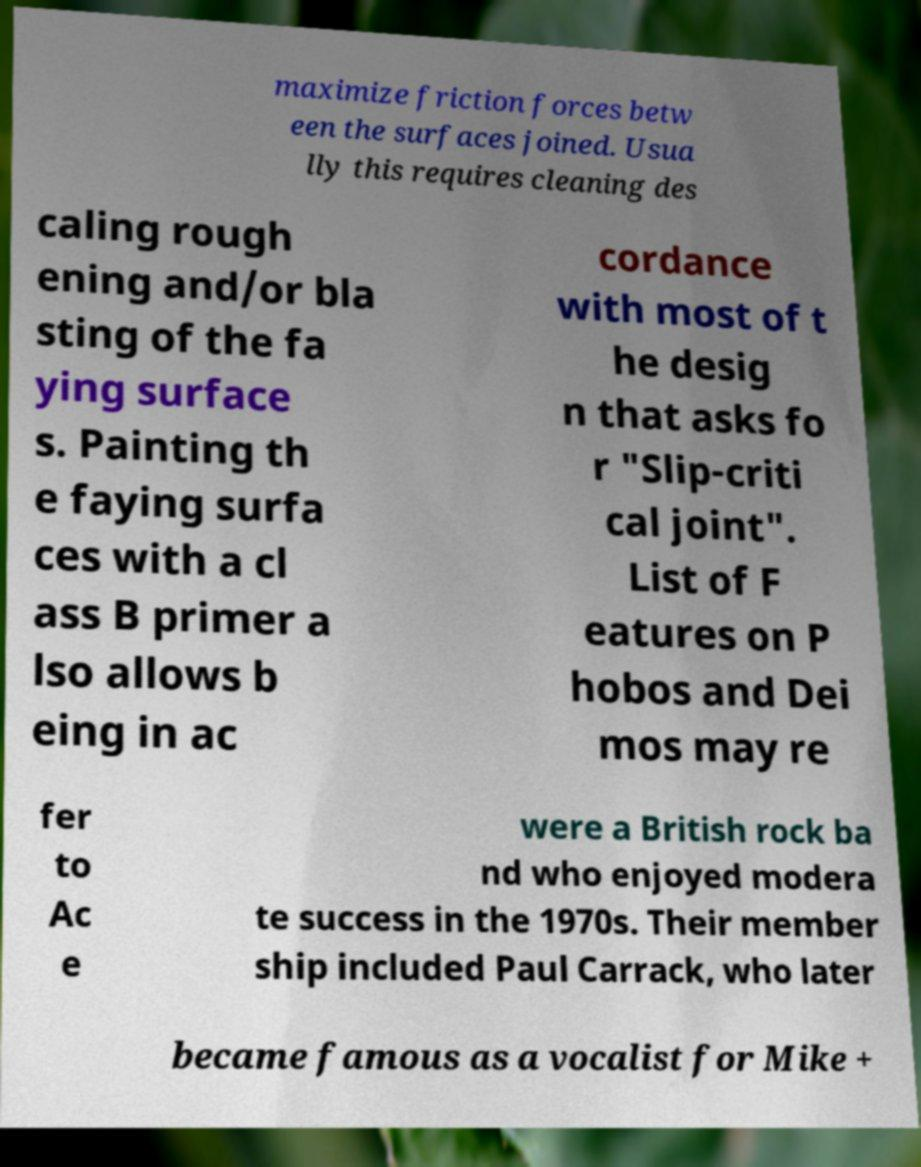Please identify and transcribe the text found in this image. maximize friction forces betw een the surfaces joined. Usua lly this requires cleaning des caling rough ening and/or bla sting of the fa ying surface s. Painting th e faying surfa ces with a cl ass B primer a lso allows b eing in ac cordance with most of t he desig n that asks fo r "Slip-criti cal joint". List of F eatures on P hobos and Dei mos may re fer to Ac e were a British rock ba nd who enjoyed modera te success in the 1970s. Their member ship included Paul Carrack, who later became famous as a vocalist for Mike + 